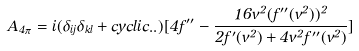<formula> <loc_0><loc_0><loc_500><loc_500>A _ { 4 \pi } = i ( \delta _ { i j } \delta _ { k l } + c y c l i c . . ) [ 4 f ^ { \prime \prime } - \frac { 1 6 v ^ { 2 } ( f ^ { \prime \prime } ( v ^ { 2 } ) ) ^ { 2 } } { 2 f ^ { \prime } ( v ^ { 2 } ) + 4 v ^ { 2 } f ^ { \prime \prime } ( v ^ { 2 } ) } ]</formula> 